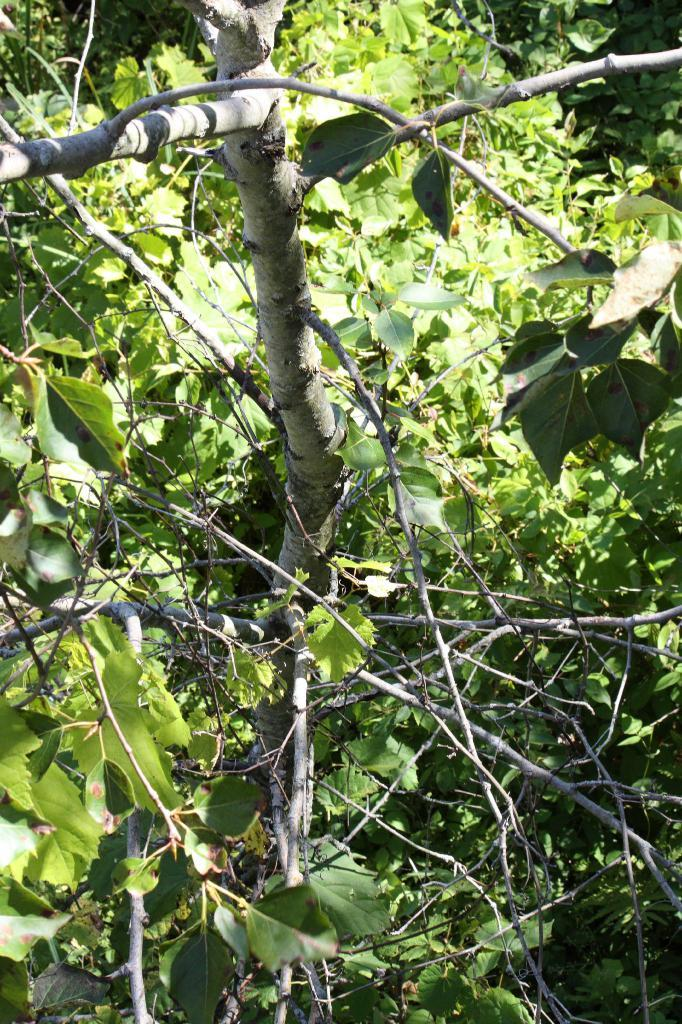What is the main subject in the middle of the image? There is a tree in the middle of the image. What can be found at the bottom of the tree? Dry sticks are present at the bottom of the tree. What is the color of the leaves on the tree? Green leaves are visible on the tree. What type of wax can be seen dripping from the tree in the image? There is no wax present in the image; it features a tree with dry sticks at the bottom and green leaves. 